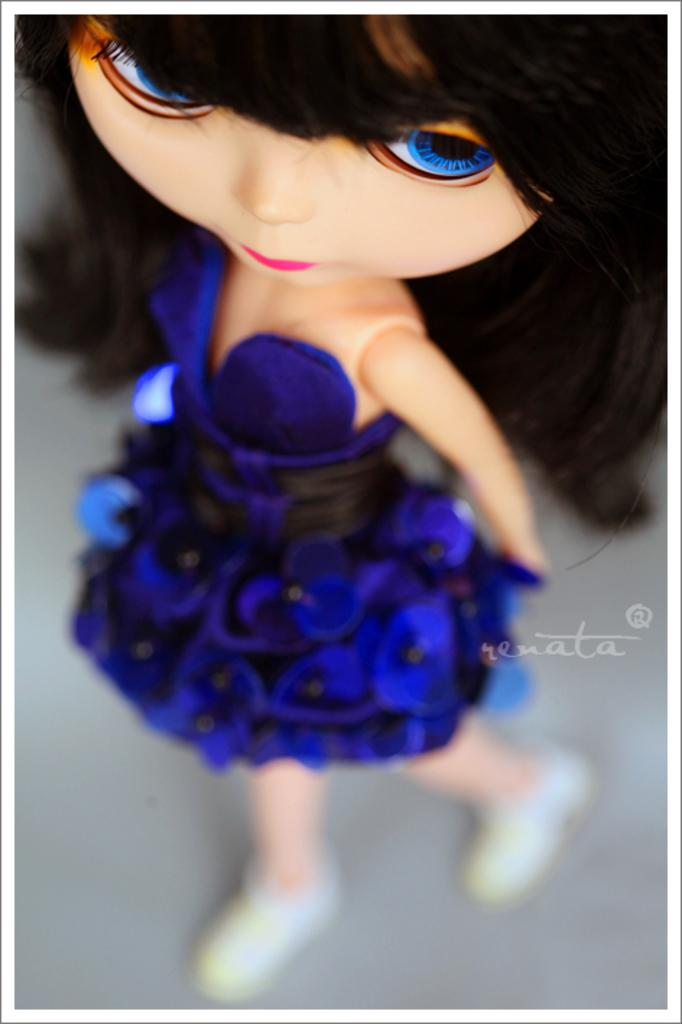What is the main subject of the image? There is a doll in the image. What is the doll wearing? The doll is wearing a blue dress and blue shoes. Where is the quartz located in the image? There is no quartz present in the image. What type of throne is the doll sitting on in the image? The image does not show the doll sitting on a throne, nor is there a throne present in the image. 